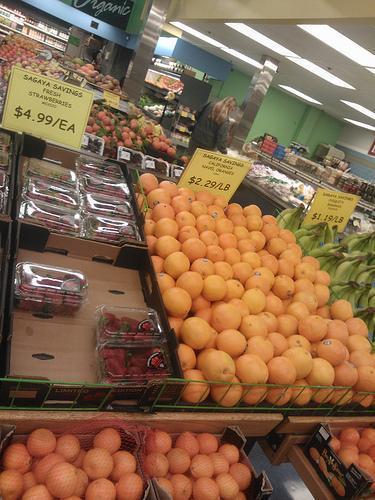How many people are in the picture?
Give a very brief answer. 1. 